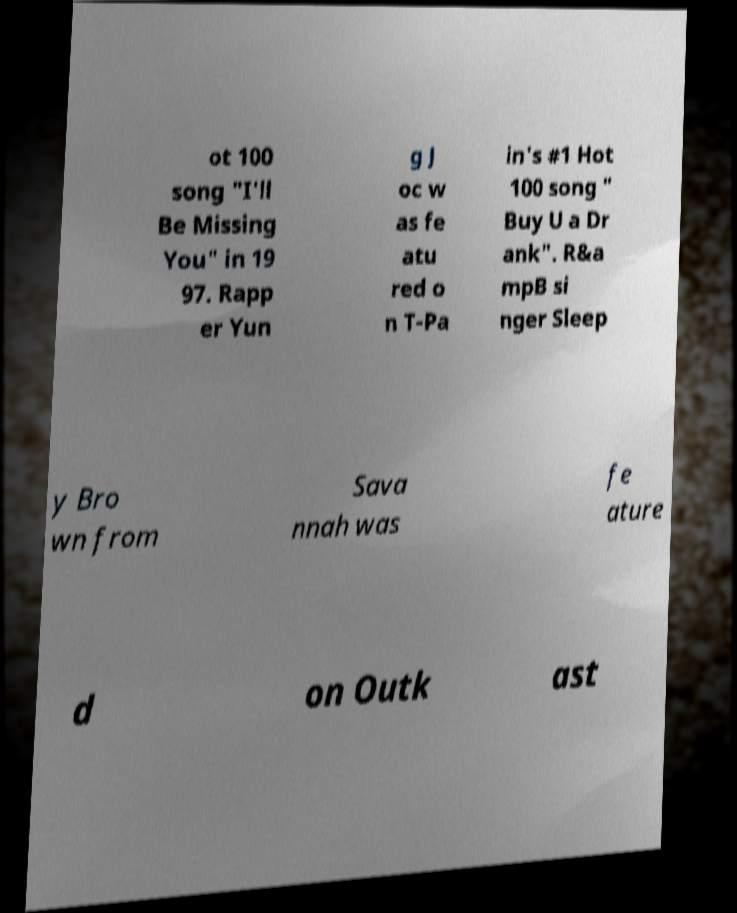There's text embedded in this image that I need extracted. Can you transcribe it verbatim? ot 100 song "I'll Be Missing You" in 19 97. Rapp er Yun g J oc w as fe atu red o n T-Pa in's #1 Hot 100 song " Buy U a Dr ank". R&a mpB si nger Sleep y Bro wn from Sava nnah was fe ature d on Outk ast 